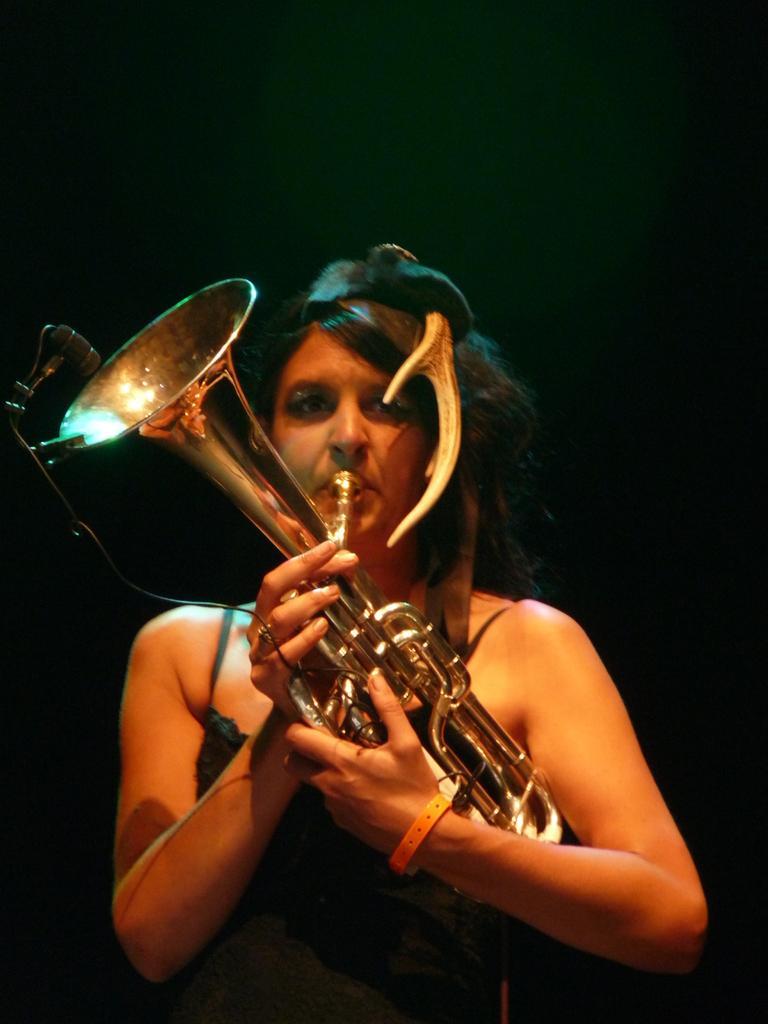In one or two sentences, can you explain what this image depicts? In the center of the image there is a lady holding a musical instrument in her hands. 